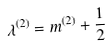<formula> <loc_0><loc_0><loc_500><loc_500>\lambda ^ { ( 2 ) } = m ^ { ( 2 ) } + \frac { 1 } { 2 }</formula> 